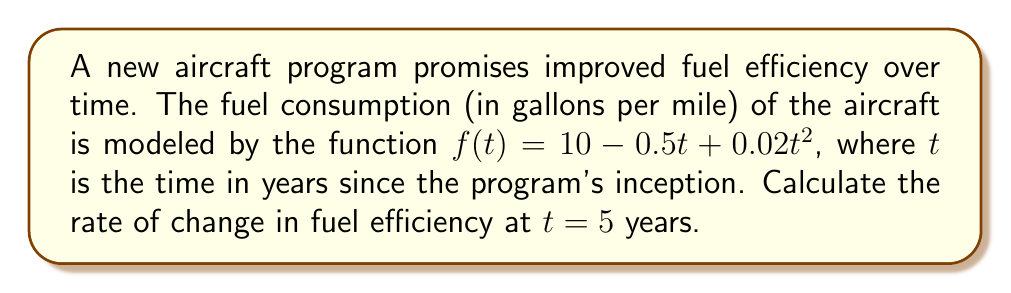Can you answer this question? To find the rate of change in fuel efficiency at $t = 5$ years, we need to calculate the derivative of the fuel consumption function and evaluate it at $t = 5$.

Step 1: Find the derivative of $f(t)$.
$$f(t) = 10 - 0.5t + 0.02t^2$$
$$f'(t) = -0.5 + 0.04t$$

Step 2: Evaluate $f'(t)$ at $t = 5$.
$$f'(5) = -0.5 + 0.04(5)$$
$$f'(5) = -0.5 + 0.2$$
$$f'(5) = -0.3$$

Step 3: Interpret the result.
The negative value indicates that fuel consumption is decreasing, which means fuel efficiency is improving. The rate of change is 0.3 gallons per mile per year at $t = 5$ years.

Step 4: Convert to a more intuitive measure.
To express this in terms of improved efficiency:
$$\text{Efficiency improvement} = -f'(5) = 0.3 \text{ gallons per mile per year}$$

This means the aircraft is becoming more fuel-efficient at a rate of 0.3 gallons per mile each year, at the 5-year mark of the program.
Answer: $0.3$ gallons per mile per year 